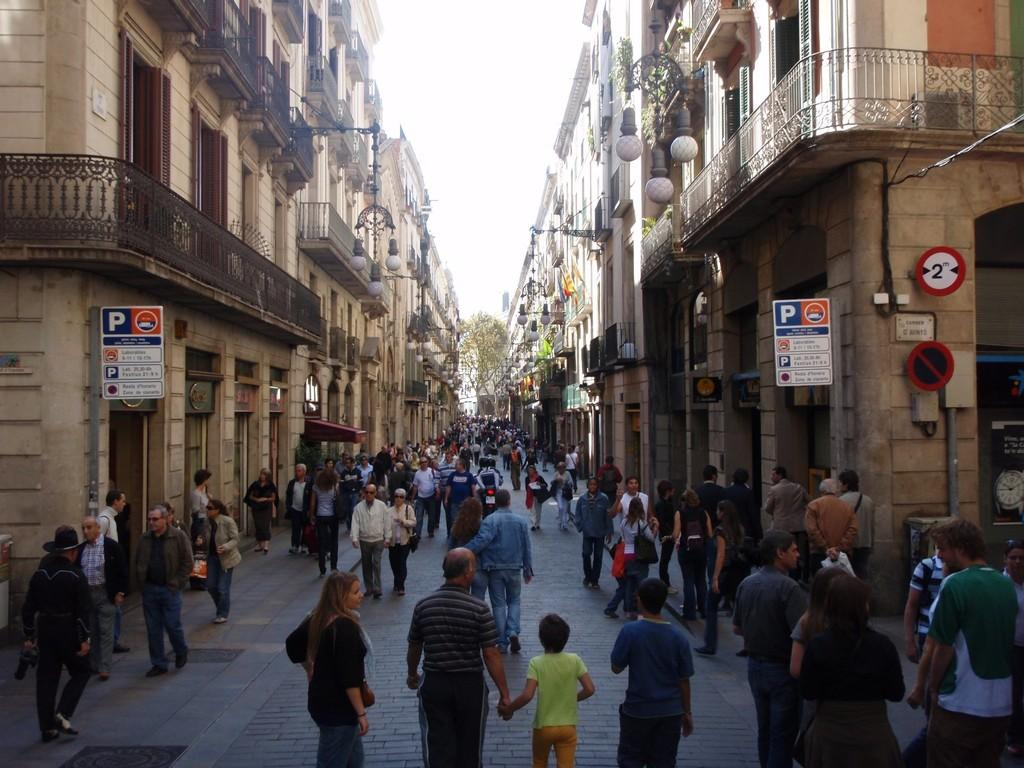What are the people in the image doing? The people in the image are walking. What type of natural elements can be seen in the image? There are trees in the image. What type of man-made structures are visible on the left side of the image? There are buildings on the left side of the image. What type of man-made structures are visible on the right side of the image? There are buildings on the right side of the image. What type of signage or information boards can be seen in the image? There are written text boards in the image. What type of pollution is visible in the image? There is no visible pollution in the image. What scientific theory is being demonstrated in the image? There is no scientific theory being demonstrated in the image. 